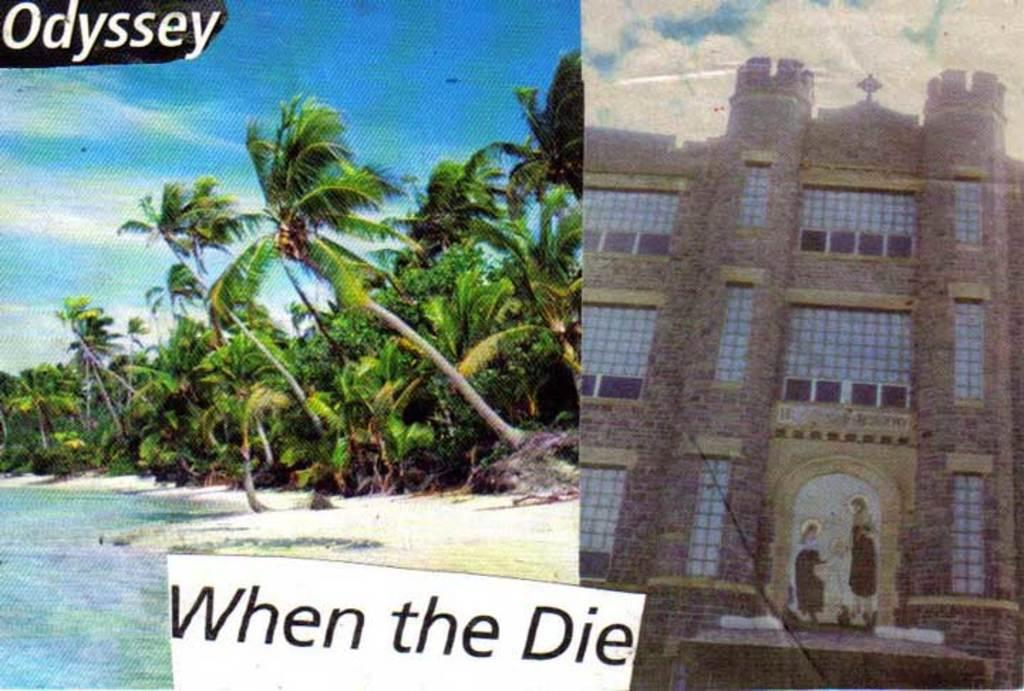What type of artwork is the image? The image is a collage. What natural elements are present in the image? There are trees and water in the image. Where is the building located in the image? The building is on the right side of the image. What is written or depicted at the bottom of the image? There is text at the bottom of the image. How long does it take for the quilt to be sewn in the image? There is no quilt present in the image, so it is not possible to determine how long it would take to sew one. Can you tell me how many scissors are used in the image? There are no scissors visible in the image. 